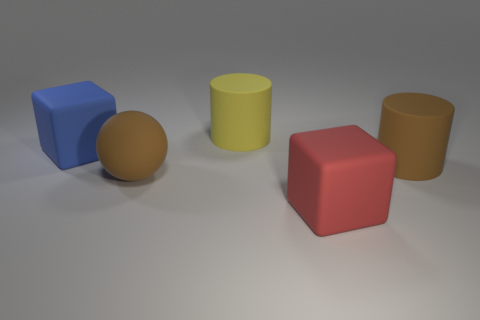Add 1 large brown spheres. How many objects exist? 6 Subtract all cubes. How many objects are left? 3 Subtract 0 brown cubes. How many objects are left? 5 Subtract all blue matte spheres. Subtract all brown matte objects. How many objects are left? 3 Add 2 matte cylinders. How many matte cylinders are left? 4 Add 5 big matte spheres. How many big matte spheres exist? 6 